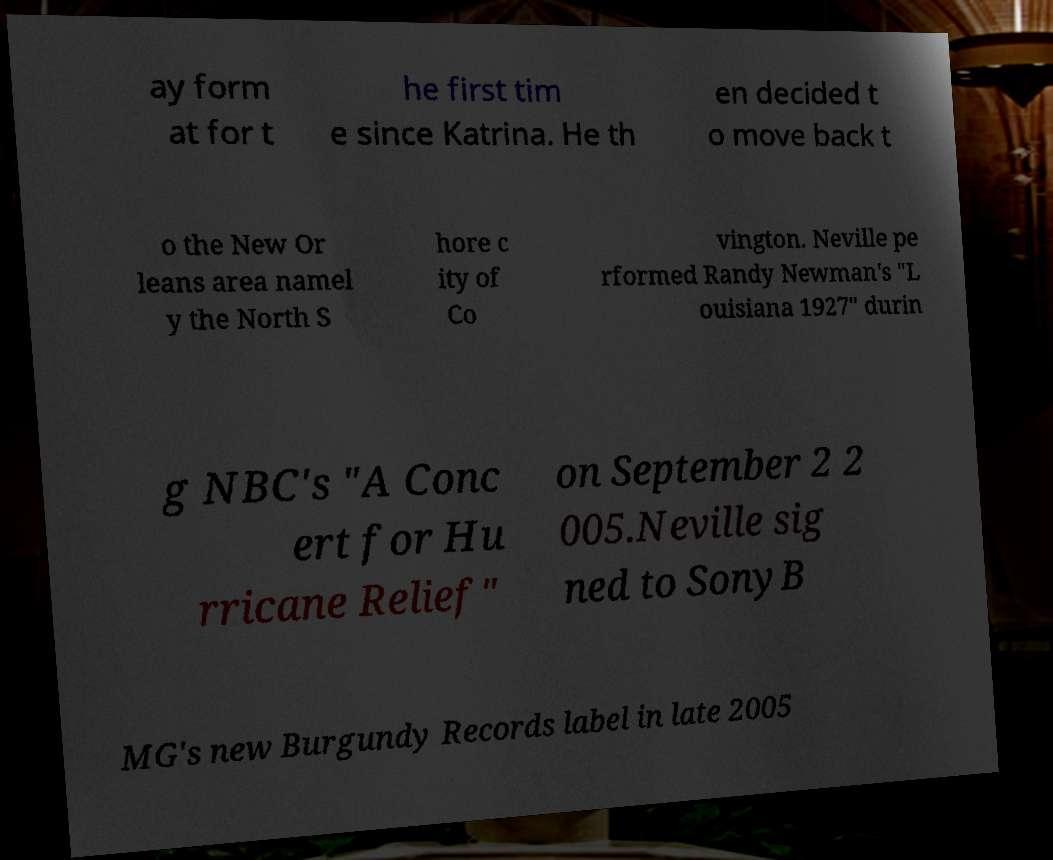Could you assist in decoding the text presented in this image and type it out clearly? ay form at for t he first tim e since Katrina. He th en decided t o move back t o the New Or leans area namel y the North S hore c ity of Co vington. Neville pe rformed Randy Newman's "L ouisiana 1927" durin g NBC's "A Conc ert for Hu rricane Relief" on September 2 2 005.Neville sig ned to SonyB MG's new Burgundy Records label in late 2005 